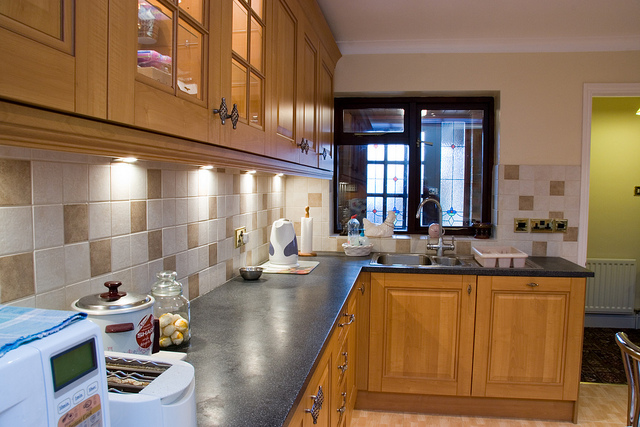Can you describe the style or ambiance of this kitchen? Certainly, the kitchen exhibits a warm, traditional ambiance with wooden cabinets and a tiled backsplash that create a cozy and inviting atmosphere. The dark countertops provide a nice contrast to the light wooden tones, and the overall design suggests a functional yet aesthetically pleasing space. 